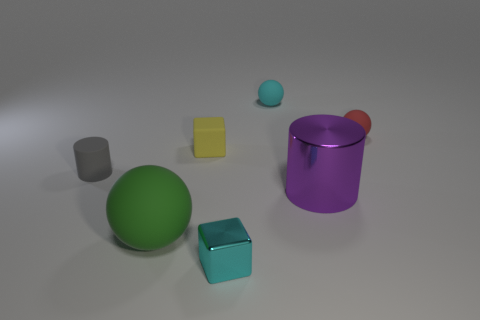There is a matte object that is the same shape as the small cyan metal thing; what color is it?
Provide a succinct answer. Yellow. What number of objects are either red metallic blocks or matte things left of the cyan matte thing?
Provide a succinct answer. 3. Are there fewer cyan blocks in front of the purple shiny object than rubber objects?
Provide a short and direct response. Yes. What size is the cylinder that is in front of the gray cylinder behind the cyan thing that is in front of the tiny yellow matte block?
Offer a terse response. Large. What color is the thing that is both in front of the small gray matte cylinder and on the left side of the cyan block?
Keep it short and to the point. Green. How many large yellow metallic things are there?
Make the answer very short. 0. Does the tiny yellow block have the same material as the tiny cyan block?
Your answer should be compact. No. Is the size of the block on the left side of the metal block the same as the shiny thing that is right of the cyan shiny thing?
Provide a short and direct response. No. Are there fewer small cyan shiny objects than metallic things?
Provide a short and direct response. Yes. How many rubber objects are either purple objects or cubes?
Offer a terse response. 1. 